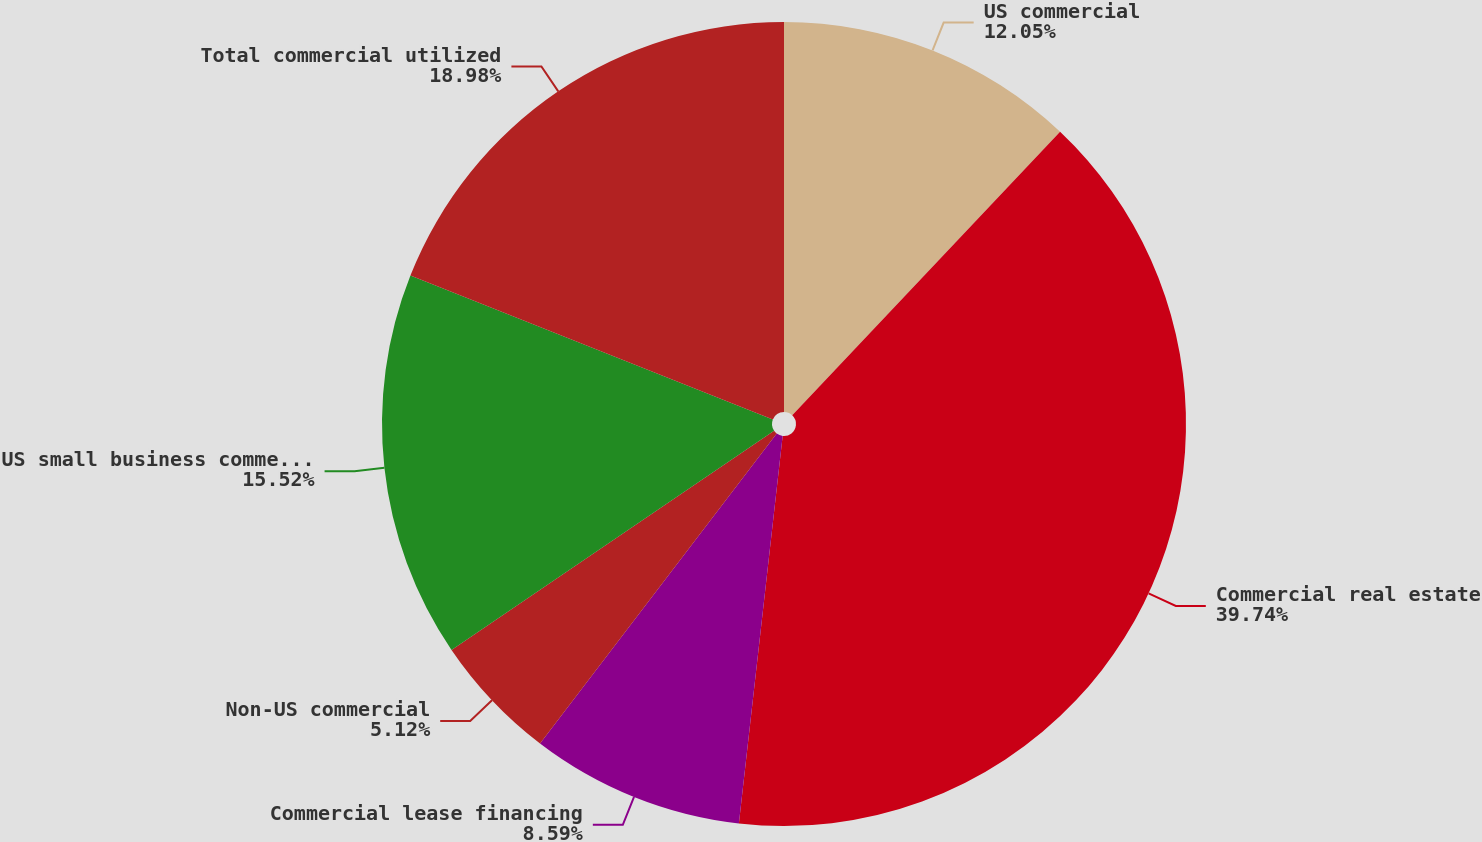<chart> <loc_0><loc_0><loc_500><loc_500><pie_chart><fcel>US commercial<fcel>Commercial real estate<fcel>Commercial lease financing<fcel>Non-US commercial<fcel>US small business commercial<fcel>Total commercial utilized<nl><fcel>12.05%<fcel>39.74%<fcel>8.59%<fcel>5.12%<fcel>15.52%<fcel>18.98%<nl></chart> 